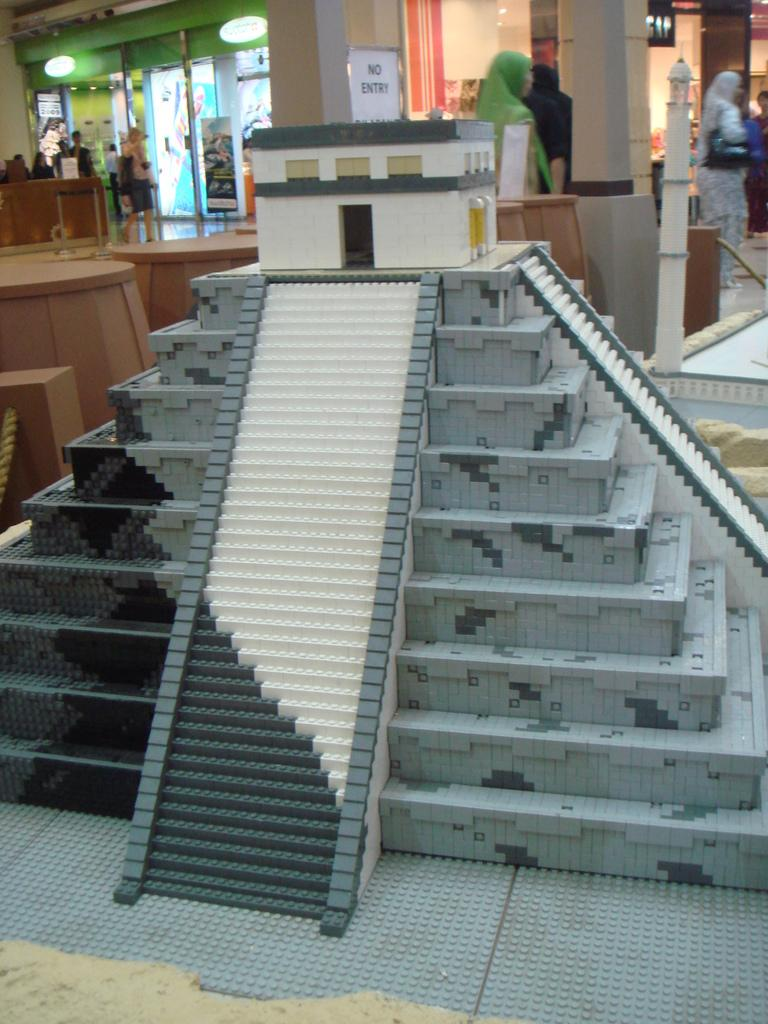What is the main subject of the image? The main subject of the image is a pyramid statue. Are there any other people in the image besides the statue? Yes, there are other people standing behind the statue. What additional information can be gathered from the image? There is a sign board in the image with the text "No Entry" written on it. What type of drug is being distributed by the achiever in the image? There is no achiever or drug present in the image. The image features a pyramid statue, people standing behind it, and a sign board with the text "No Entry." 